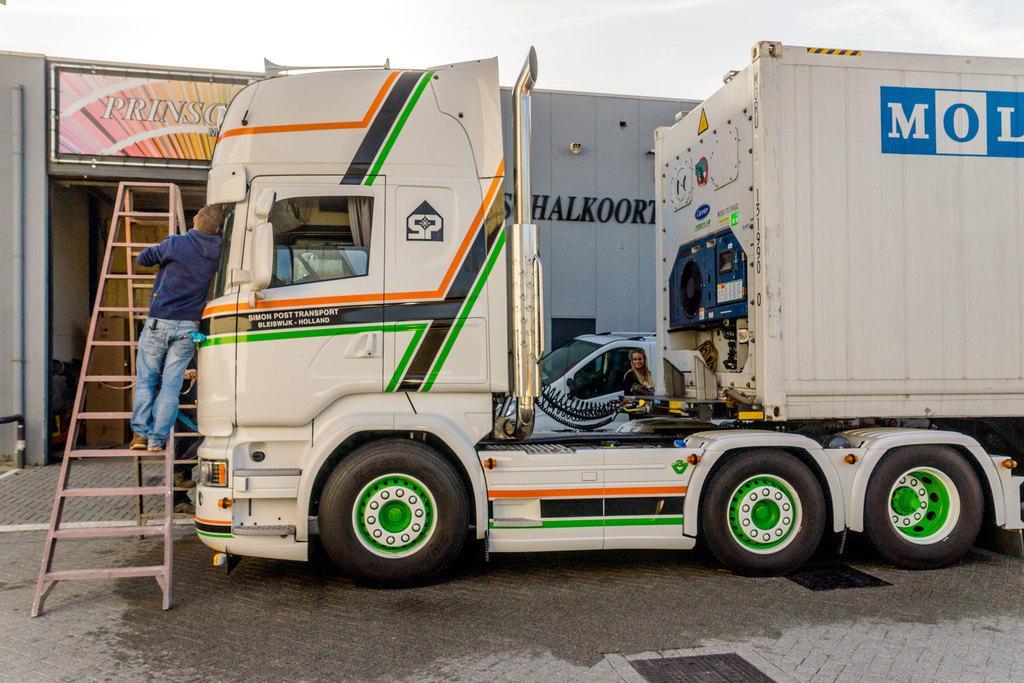In one or two sentences, can you explain what this image depicts? In this image in the center there is one vehicle, and on the left side there is one ladder and on the ladder there is one person. And in the background there is another vehicle and one woman and building, on the building there is text and one board. On the board there is text and also there is one pole, at the bottom there is a walkway. 